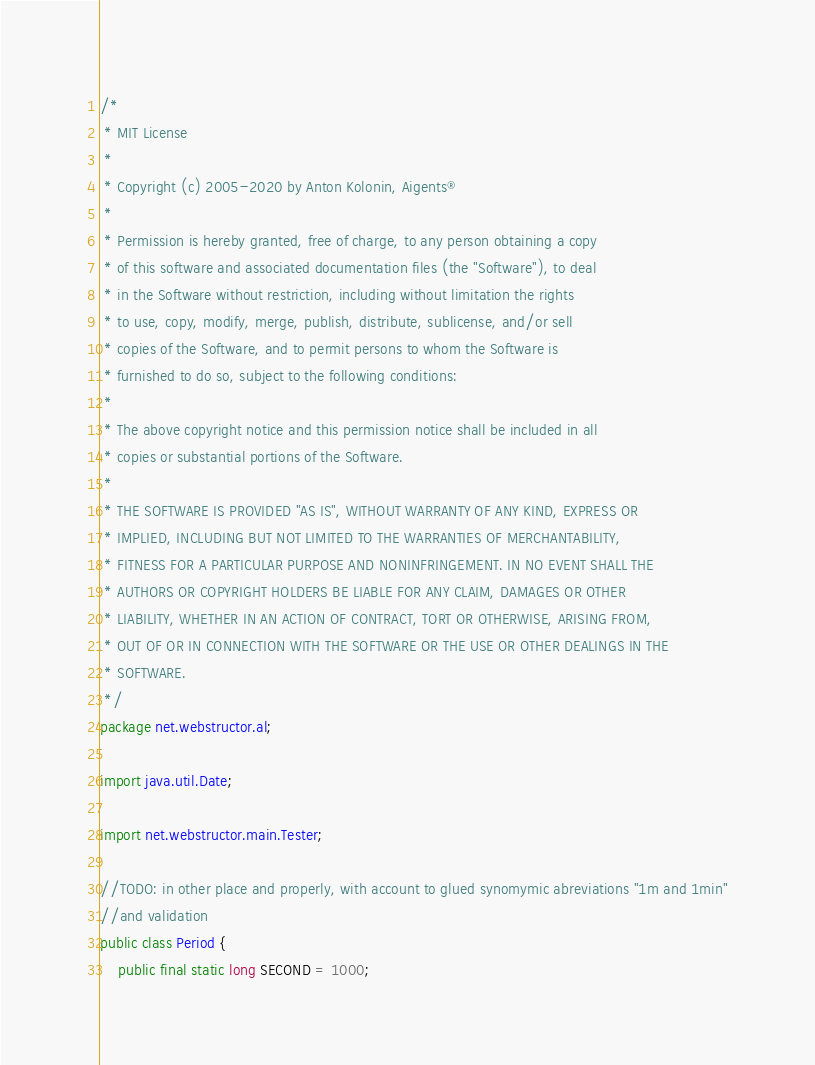Convert code to text. <code><loc_0><loc_0><loc_500><loc_500><_Java_>/*
 * MIT License
 * 
 * Copyright (c) 2005-2020 by Anton Kolonin, Aigents®
 *
 * Permission is hereby granted, free of charge, to any person obtaining a copy
 * of this software and associated documentation files (the "Software"), to deal
 * in the Software without restriction, including without limitation the rights
 * to use, copy, modify, merge, publish, distribute, sublicense, and/or sell
 * copies of the Software, and to permit persons to whom the Software is
 * furnished to do so, subject to the following conditions:
 *
 * The above copyright notice and this permission notice shall be included in all
 * copies or substantial portions of the Software.
 *
 * THE SOFTWARE IS PROVIDED "AS IS", WITHOUT WARRANTY OF ANY KIND, EXPRESS OR
 * IMPLIED, INCLUDING BUT NOT LIMITED TO THE WARRANTIES OF MERCHANTABILITY,
 * FITNESS FOR A PARTICULAR PURPOSE AND NONINFRINGEMENT. IN NO EVENT SHALL THE
 * AUTHORS OR COPYRIGHT HOLDERS BE LIABLE FOR ANY CLAIM, DAMAGES OR OTHER
 * LIABILITY, WHETHER IN AN ACTION OF CONTRACT, TORT OR OTHERWISE, ARISING FROM,
 * OUT OF OR IN CONNECTION WITH THE SOFTWARE OR THE USE OR OTHER DEALINGS IN THE
 * SOFTWARE.
 */
package net.webstructor.al;

import java.util.Date;

import net.webstructor.main.Tester;

//TODO: in other place and properly, with account to glued synomymic abreviations "1m and 1min"
//and validation
public class Period {
	public final static long SECOND = 1000;</code> 